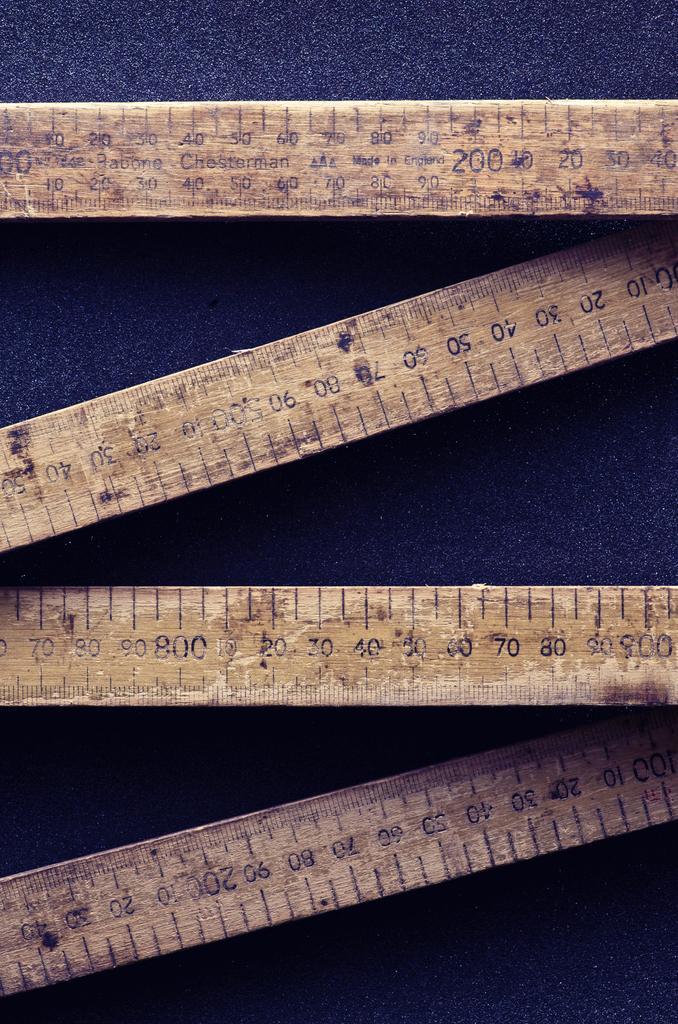Describe this image in one or two sentences. In this image I can see four wooden scales which are placed on a blue color sheet. 